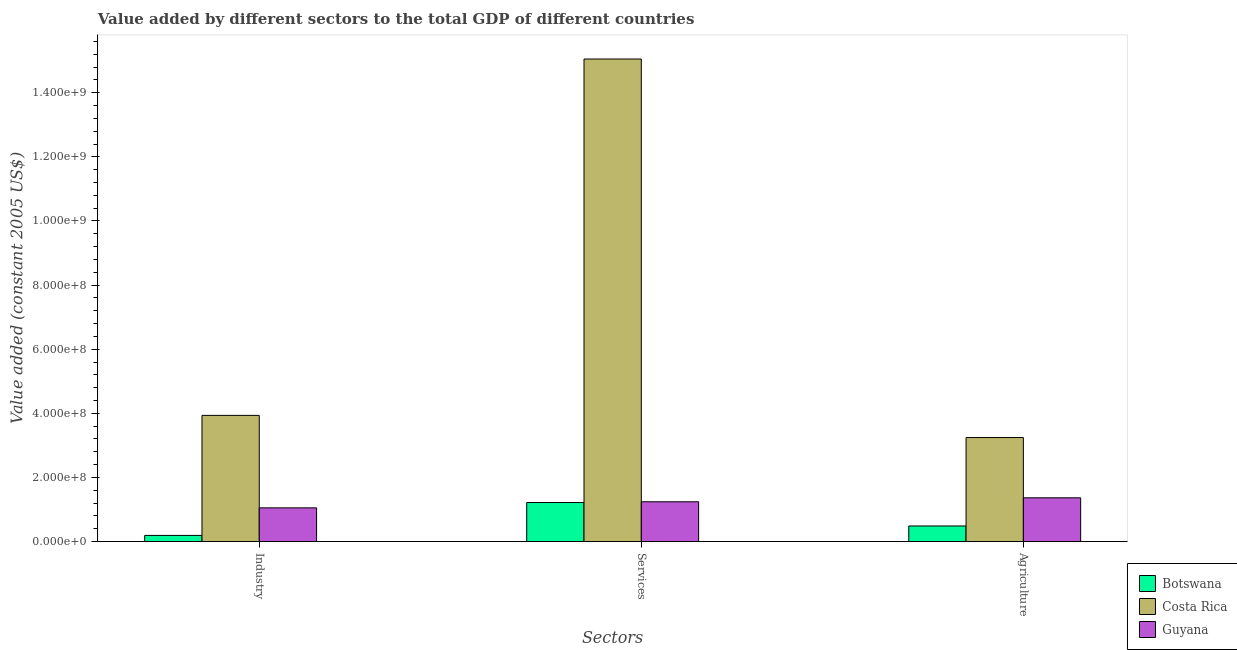How many different coloured bars are there?
Provide a succinct answer. 3. How many groups of bars are there?
Offer a terse response. 3. Are the number of bars on each tick of the X-axis equal?
Make the answer very short. Yes. How many bars are there on the 1st tick from the left?
Keep it short and to the point. 3. How many bars are there on the 1st tick from the right?
Offer a terse response. 3. What is the label of the 3rd group of bars from the left?
Give a very brief answer. Agriculture. What is the value added by industrial sector in Guyana?
Provide a succinct answer. 1.05e+08. Across all countries, what is the maximum value added by services?
Provide a succinct answer. 1.51e+09. Across all countries, what is the minimum value added by services?
Keep it short and to the point. 1.22e+08. In which country was the value added by industrial sector maximum?
Your answer should be very brief. Costa Rica. In which country was the value added by services minimum?
Offer a very short reply. Botswana. What is the total value added by agricultural sector in the graph?
Provide a succinct answer. 5.10e+08. What is the difference between the value added by industrial sector in Guyana and that in Botswana?
Keep it short and to the point. 8.60e+07. What is the difference between the value added by industrial sector in Costa Rica and the value added by agricultural sector in Botswana?
Provide a succinct answer. 3.45e+08. What is the average value added by agricultural sector per country?
Provide a short and direct response. 1.70e+08. What is the difference between the value added by services and value added by agricultural sector in Costa Rica?
Give a very brief answer. 1.18e+09. In how many countries, is the value added by services greater than 1200000000 US$?
Make the answer very short. 1. What is the ratio of the value added by agricultural sector in Guyana to that in Botswana?
Ensure brevity in your answer.  2.81. Is the difference between the value added by agricultural sector in Botswana and Guyana greater than the difference between the value added by services in Botswana and Guyana?
Your answer should be very brief. No. What is the difference between the highest and the second highest value added by services?
Offer a very short reply. 1.38e+09. What is the difference between the highest and the lowest value added by industrial sector?
Offer a very short reply. 3.74e+08. What does the 2nd bar from the left in Agriculture represents?
Provide a succinct answer. Costa Rica. What does the 2nd bar from the right in Agriculture represents?
Give a very brief answer. Costa Rica. Is it the case that in every country, the sum of the value added by industrial sector and value added by services is greater than the value added by agricultural sector?
Offer a terse response. Yes. How many countries are there in the graph?
Ensure brevity in your answer.  3. What is the difference between two consecutive major ticks on the Y-axis?
Your answer should be very brief. 2.00e+08. Does the graph contain grids?
Offer a very short reply. No. Where does the legend appear in the graph?
Ensure brevity in your answer.  Bottom right. What is the title of the graph?
Ensure brevity in your answer.  Value added by different sectors to the total GDP of different countries. What is the label or title of the X-axis?
Your answer should be very brief. Sectors. What is the label or title of the Y-axis?
Your answer should be very brief. Value added (constant 2005 US$). What is the Value added (constant 2005 US$) of Botswana in Industry?
Offer a very short reply. 1.92e+07. What is the Value added (constant 2005 US$) in Costa Rica in Industry?
Your answer should be very brief. 3.94e+08. What is the Value added (constant 2005 US$) of Guyana in Industry?
Offer a terse response. 1.05e+08. What is the Value added (constant 2005 US$) in Botswana in Services?
Give a very brief answer. 1.22e+08. What is the Value added (constant 2005 US$) in Costa Rica in Services?
Your answer should be very brief. 1.51e+09. What is the Value added (constant 2005 US$) in Guyana in Services?
Your answer should be very brief. 1.24e+08. What is the Value added (constant 2005 US$) in Botswana in Agriculture?
Keep it short and to the point. 4.86e+07. What is the Value added (constant 2005 US$) of Costa Rica in Agriculture?
Keep it short and to the point. 3.24e+08. What is the Value added (constant 2005 US$) in Guyana in Agriculture?
Make the answer very short. 1.36e+08. Across all Sectors, what is the maximum Value added (constant 2005 US$) of Botswana?
Your response must be concise. 1.22e+08. Across all Sectors, what is the maximum Value added (constant 2005 US$) in Costa Rica?
Offer a very short reply. 1.51e+09. Across all Sectors, what is the maximum Value added (constant 2005 US$) in Guyana?
Provide a short and direct response. 1.36e+08. Across all Sectors, what is the minimum Value added (constant 2005 US$) of Botswana?
Ensure brevity in your answer.  1.92e+07. Across all Sectors, what is the minimum Value added (constant 2005 US$) in Costa Rica?
Your answer should be very brief. 3.24e+08. Across all Sectors, what is the minimum Value added (constant 2005 US$) of Guyana?
Provide a short and direct response. 1.05e+08. What is the total Value added (constant 2005 US$) of Botswana in the graph?
Offer a terse response. 1.90e+08. What is the total Value added (constant 2005 US$) of Costa Rica in the graph?
Your answer should be very brief. 2.22e+09. What is the total Value added (constant 2005 US$) in Guyana in the graph?
Ensure brevity in your answer.  3.66e+08. What is the difference between the Value added (constant 2005 US$) of Botswana in Industry and that in Services?
Give a very brief answer. -1.03e+08. What is the difference between the Value added (constant 2005 US$) in Costa Rica in Industry and that in Services?
Keep it short and to the point. -1.11e+09. What is the difference between the Value added (constant 2005 US$) of Guyana in Industry and that in Services?
Keep it short and to the point. -1.90e+07. What is the difference between the Value added (constant 2005 US$) of Botswana in Industry and that in Agriculture?
Ensure brevity in your answer.  -2.94e+07. What is the difference between the Value added (constant 2005 US$) in Costa Rica in Industry and that in Agriculture?
Your answer should be very brief. 6.91e+07. What is the difference between the Value added (constant 2005 US$) in Guyana in Industry and that in Agriculture?
Give a very brief answer. -3.13e+07. What is the difference between the Value added (constant 2005 US$) in Botswana in Services and that in Agriculture?
Ensure brevity in your answer.  7.32e+07. What is the difference between the Value added (constant 2005 US$) of Costa Rica in Services and that in Agriculture?
Your answer should be compact. 1.18e+09. What is the difference between the Value added (constant 2005 US$) in Guyana in Services and that in Agriculture?
Give a very brief answer. -1.23e+07. What is the difference between the Value added (constant 2005 US$) in Botswana in Industry and the Value added (constant 2005 US$) in Costa Rica in Services?
Offer a very short reply. -1.49e+09. What is the difference between the Value added (constant 2005 US$) in Botswana in Industry and the Value added (constant 2005 US$) in Guyana in Services?
Give a very brief answer. -1.05e+08. What is the difference between the Value added (constant 2005 US$) of Costa Rica in Industry and the Value added (constant 2005 US$) of Guyana in Services?
Offer a terse response. 2.69e+08. What is the difference between the Value added (constant 2005 US$) of Botswana in Industry and the Value added (constant 2005 US$) of Costa Rica in Agriculture?
Your answer should be very brief. -3.05e+08. What is the difference between the Value added (constant 2005 US$) of Botswana in Industry and the Value added (constant 2005 US$) of Guyana in Agriculture?
Offer a very short reply. -1.17e+08. What is the difference between the Value added (constant 2005 US$) in Costa Rica in Industry and the Value added (constant 2005 US$) in Guyana in Agriculture?
Offer a terse response. 2.57e+08. What is the difference between the Value added (constant 2005 US$) of Botswana in Services and the Value added (constant 2005 US$) of Costa Rica in Agriculture?
Your answer should be compact. -2.03e+08. What is the difference between the Value added (constant 2005 US$) of Botswana in Services and the Value added (constant 2005 US$) of Guyana in Agriculture?
Your response must be concise. -1.47e+07. What is the difference between the Value added (constant 2005 US$) in Costa Rica in Services and the Value added (constant 2005 US$) in Guyana in Agriculture?
Your answer should be very brief. 1.37e+09. What is the average Value added (constant 2005 US$) in Botswana per Sectors?
Keep it short and to the point. 6.32e+07. What is the average Value added (constant 2005 US$) of Costa Rica per Sectors?
Your response must be concise. 7.41e+08. What is the average Value added (constant 2005 US$) in Guyana per Sectors?
Give a very brief answer. 1.22e+08. What is the difference between the Value added (constant 2005 US$) of Botswana and Value added (constant 2005 US$) of Costa Rica in Industry?
Provide a succinct answer. -3.74e+08. What is the difference between the Value added (constant 2005 US$) in Botswana and Value added (constant 2005 US$) in Guyana in Industry?
Ensure brevity in your answer.  -8.60e+07. What is the difference between the Value added (constant 2005 US$) in Costa Rica and Value added (constant 2005 US$) in Guyana in Industry?
Give a very brief answer. 2.88e+08. What is the difference between the Value added (constant 2005 US$) of Botswana and Value added (constant 2005 US$) of Costa Rica in Services?
Offer a very short reply. -1.38e+09. What is the difference between the Value added (constant 2005 US$) of Botswana and Value added (constant 2005 US$) of Guyana in Services?
Ensure brevity in your answer.  -2.37e+06. What is the difference between the Value added (constant 2005 US$) of Costa Rica and Value added (constant 2005 US$) of Guyana in Services?
Make the answer very short. 1.38e+09. What is the difference between the Value added (constant 2005 US$) of Botswana and Value added (constant 2005 US$) of Costa Rica in Agriculture?
Offer a terse response. -2.76e+08. What is the difference between the Value added (constant 2005 US$) of Botswana and Value added (constant 2005 US$) of Guyana in Agriculture?
Keep it short and to the point. -8.79e+07. What is the difference between the Value added (constant 2005 US$) in Costa Rica and Value added (constant 2005 US$) in Guyana in Agriculture?
Provide a short and direct response. 1.88e+08. What is the ratio of the Value added (constant 2005 US$) of Botswana in Industry to that in Services?
Keep it short and to the point. 0.16. What is the ratio of the Value added (constant 2005 US$) of Costa Rica in Industry to that in Services?
Your answer should be compact. 0.26. What is the ratio of the Value added (constant 2005 US$) of Guyana in Industry to that in Services?
Your answer should be compact. 0.85. What is the ratio of the Value added (constant 2005 US$) of Botswana in Industry to that in Agriculture?
Provide a succinct answer. 0.39. What is the ratio of the Value added (constant 2005 US$) of Costa Rica in Industry to that in Agriculture?
Your answer should be compact. 1.21. What is the ratio of the Value added (constant 2005 US$) in Guyana in Industry to that in Agriculture?
Your answer should be very brief. 0.77. What is the ratio of the Value added (constant 2005 US$) in Botswana in Services to that in Agriculture?
Your answer should be compact. 2.5. What is the ratio of the Value added (constant 2005 US$) of Costa Rica in Services to that in Agriculture?
Offer a terse response. 4.64. What is the ratio of the Value added (constant 2005 US$) in Guyana in Services to that in Agriculture?
Your response must be concise. 0.91. What is the difference between the highest and the second highest Value added (constant 2005 US$) of Botswana?
Provide a short and direct response. 7.32e+07. What is the difference between the highest and the second highest Value added (constant 2005 US$) of Costa Rica?
Make the answer very short. 1.11e+09. What is the difference between the highest and the second highest Value added (constant 2005 US$) of Guyana?
Your response must be concise. 1.23e+07. What is the difference between the highest and the lowest Value added (constant 2005 US$) of Botswana?
Your answer should be compact. 1.03e+08. What is the difference between the highest and the lowest Value added (constant 2005 US$) of Costa Rica?
Your answer should be compact. 1.18e+09. What is the difference between the highest and the lowest Value added (constant 2005 US$) in Guyana?
Ensure brevity in your answer.  3.13e+07. 